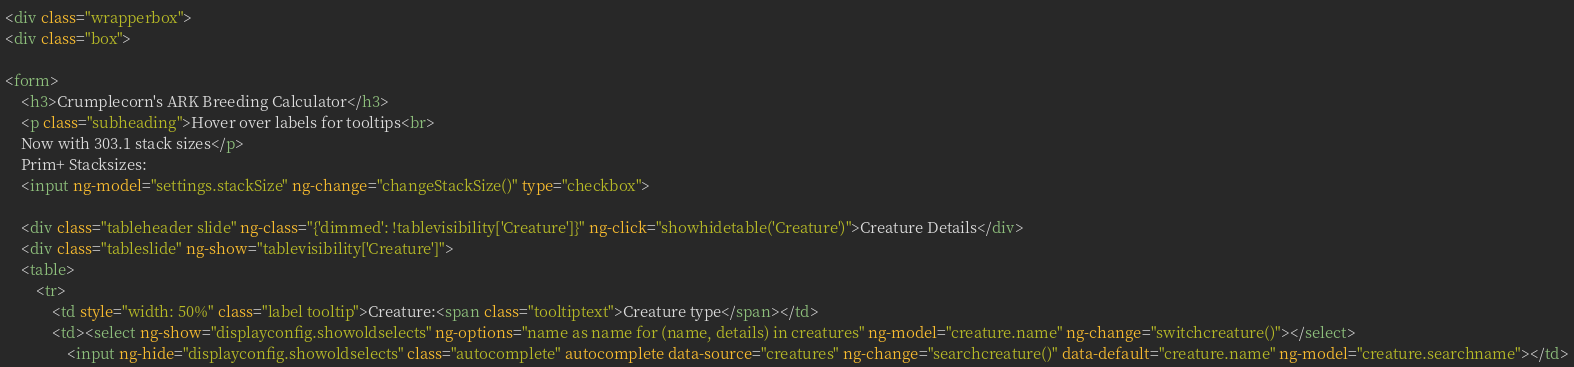<code> <loc_0><loc_0><loc_500><loc_500><_HTML_><div class="wrapperbox">
<div class="box">
	
<form>
	<h3>Crumplecorn's ARK Breeding Calculator</h3>
	<p class="subheading">Hover over labels for tooltips<br>
	Now with 303.1 stack sizes</p>
	Prim+ Stacksizes:
	<input ng-model="settings.stackSize" ng-change="changeStackSize()" type="checkbox">

	<div class="tableheader slide" ng-class="{'dimmed': !tablevisibility['Creature']}" ng-click="showhidetable('Creature')">Creature Details</div>
	<div class="tableslide" ng-show="tablevisibility['Creature']">
	<table>
		<tr>
			<td style="width: 50%" class="label tooltip">Creature:<span class="tooltiptext">Creature type</span></td>
			<td><select ng-show="displayconfig.showoldselects" ng-options="name as name for (name, details) in creatures" ng-model="creature.name" ng-change="switchcreature()"></select>
				<input ng-hide="displayconfig.showoldselects" class="autocomplete" autocomplete data-source="creatures" ng-change="searchcreature()" data-default="creature.name" ng-model="creature.searchname"></td></code> 